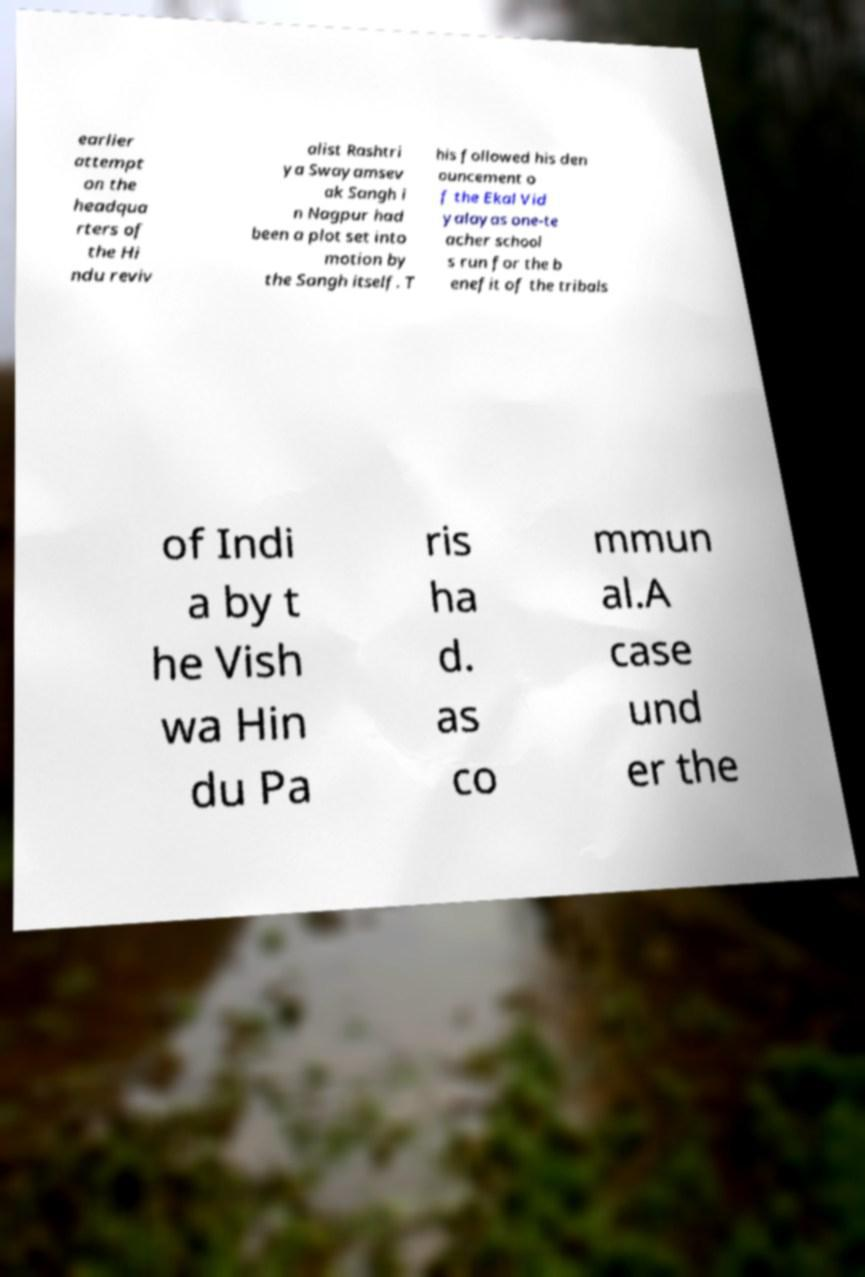Could you extract and type out the text from this image? earlier attempt on the headqua rters of the Hi ndu reviv alist Rashtri ya Swayamsev ak Sangh i n Nagpur had been a plot set into motion by the Sangh itself. T his followed his den ouncement o f the Ekal Vid yalayas one-te acher school s run for the b enefit of the tribals of Indi a by t he Vish wa Hin du Pa ris ha d. as co mmun al.A case und er the 